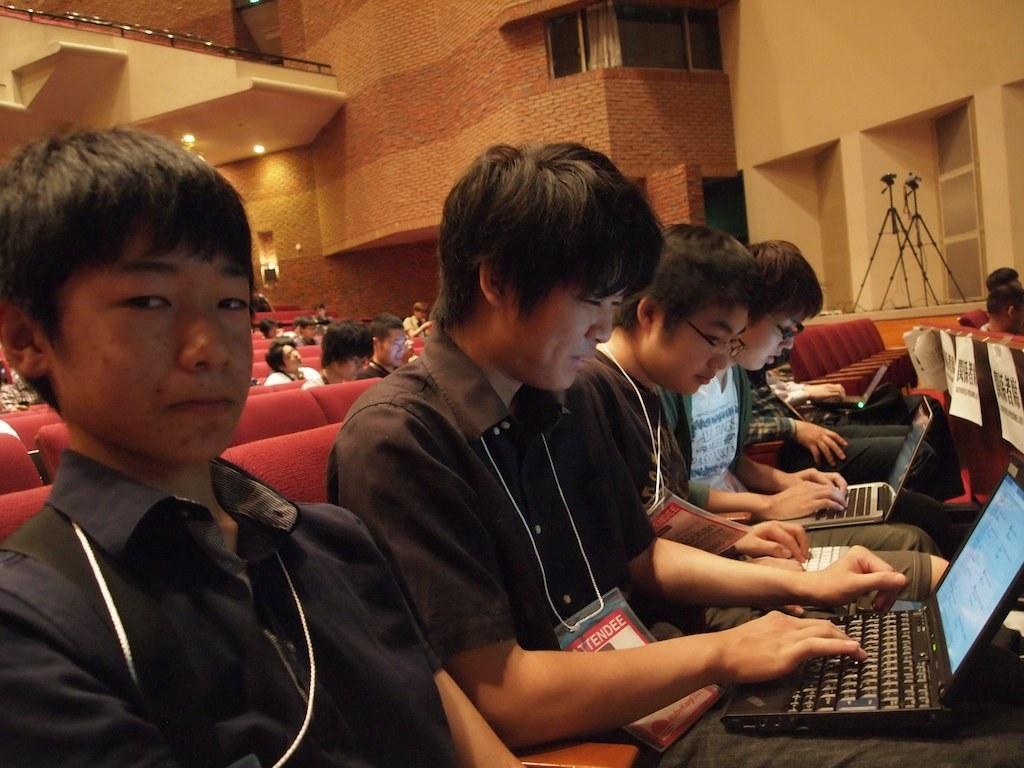Please provide a concise description of this image. In the image there are a group of people in the foreground and they are working with laptops, behind them there are many empty chairs and in the background there is a wall, on the right side there are two cameras with the stands. 